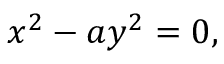<formula> <loc_0><loc_0><loc_500><loc_500>x ^ { 2 } - a y ^ { 2 } = 0 ,</formula> 